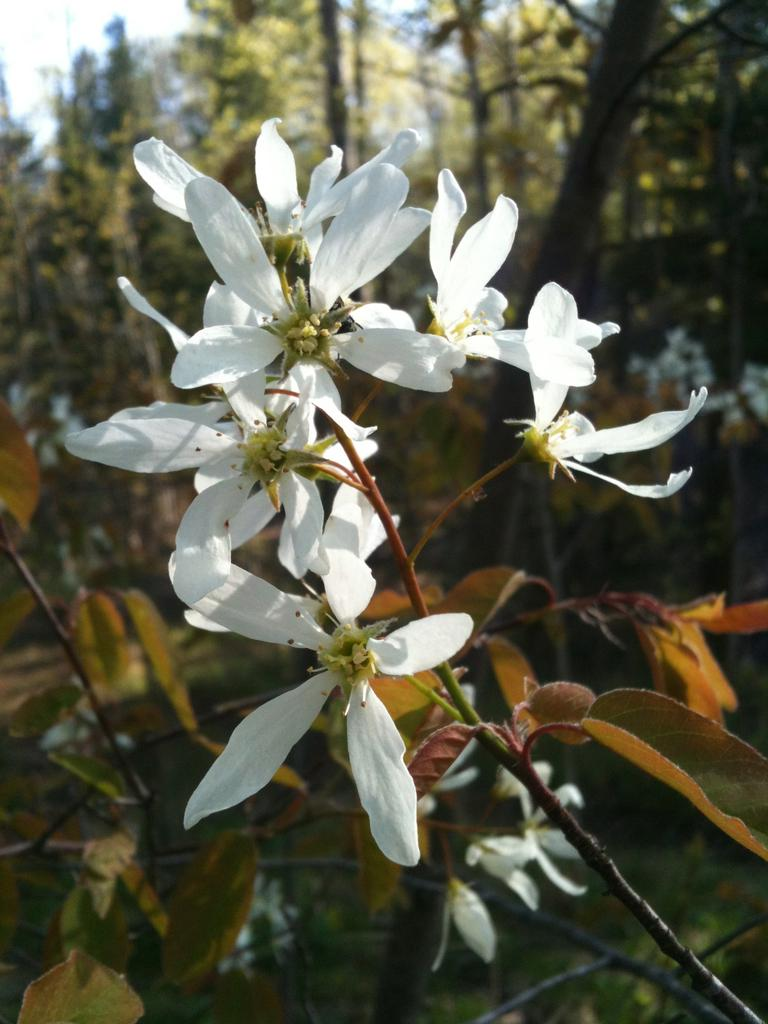What type of flowers can be seen in the image? There are white color flowers in the image. How are the flowers arranged in the image? The flowers are attached to a stem. What can be seen in the background of the image? There are many trees in the background of the image. What is visible at the top of the image? The sky is visible at the top of the image. How far away is the baseball field from the flowers in the image? There is no baseball field present in the image, so it is not possible to determine the distance between the flowers and a baseball field. 